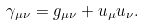<formula> <loc_0><loc_0><loc_500><loc_500>\gamma _ { \mu \nu } = g _ { \mu \nu } + u _ { \mu } u _ { \nu } .</formula> 